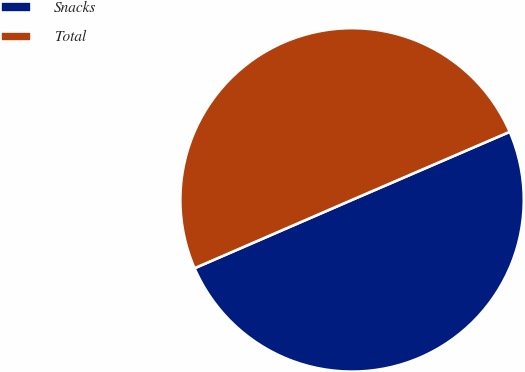Convert chart. <chart><loc_0><loc_0><loc_500><loc_500><pie_chart><fcel>Snacks<fcel>Total<nl><fcel>49.97%<fcel>50.03%<nl></chart> 